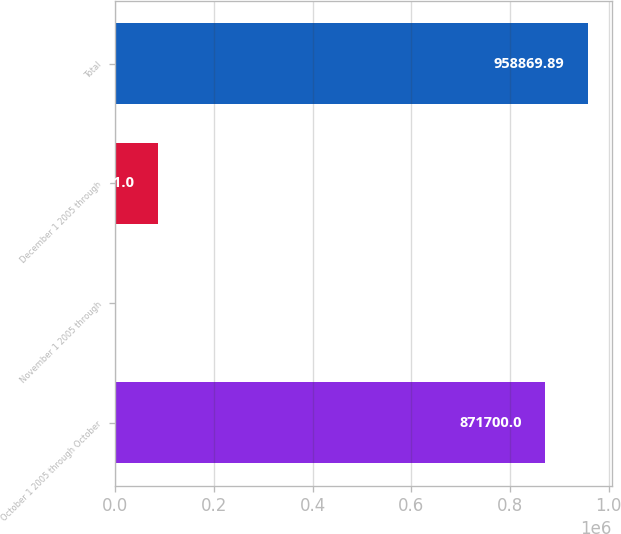<chart> <loc_0><loc_0><loc_500><loc_500><bar_chart><fcel>October 1 2005 through October<fcel>November 1 2005 through<fcel>December 1 2005 through<fcel>Total<nl><fcel>871700<fcel>1.11<fcel>87171<fcel>958870<nl></chart> 